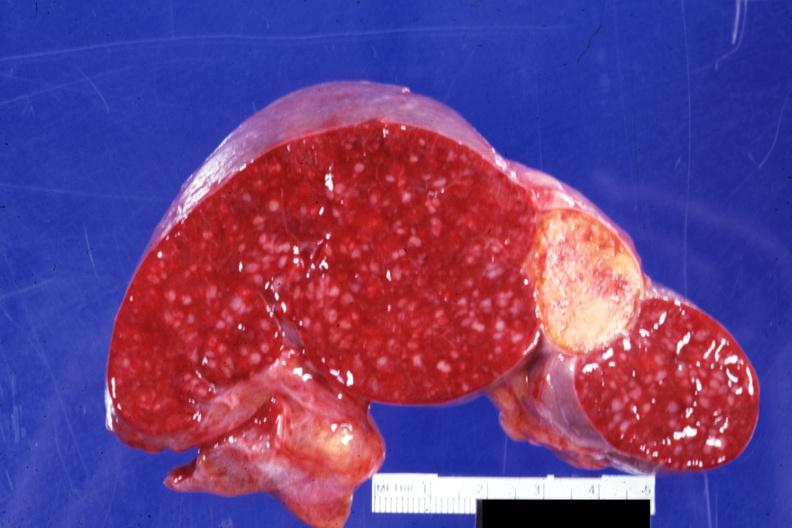what is present?
Answer the question using a single word or phrase. Spleen 